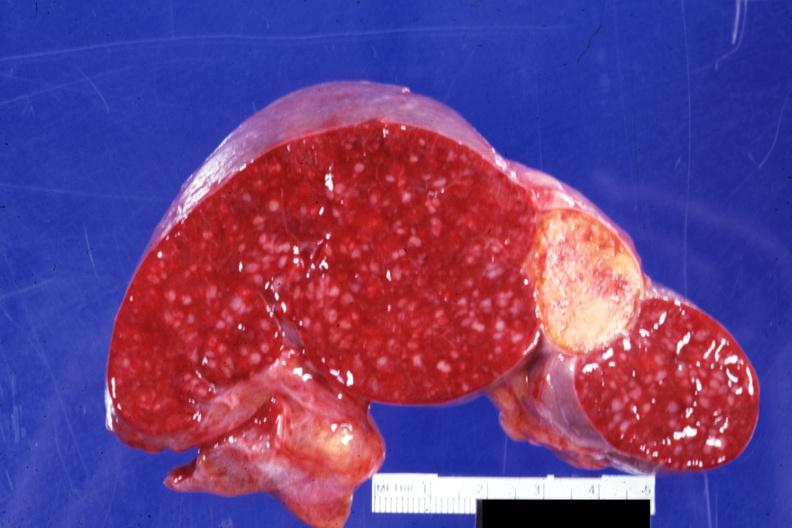what is present?
Answer the question using a single word or phrase. Spleen 